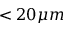Convert formula to latex. <formula><loc_0><loc_0><loc_500><loc_500>< 2 0 \mu m</formula> 